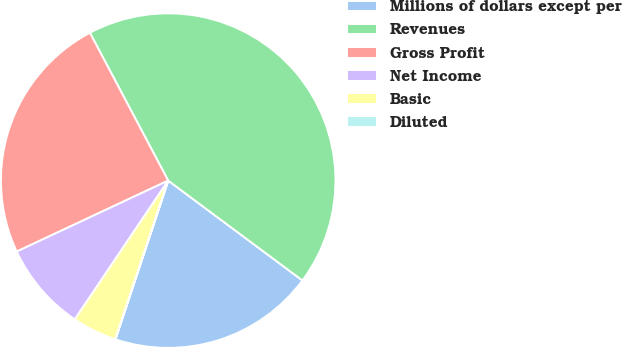Convert chart. <chart><loc_0><loc_0><loc_500><loc_500><pie_chart><fcel>Millions of dollars except per<fcel>Revenues<fcel>Gross Profit<fcel>Net Income<fcel>Basic<fcel>Diluted<nl><fcel>19.93%<fcel>42.93%<fcel>24.22%<fcel>8.6%<fcel>4.31%<fcel>0.01%<nl></chart> 